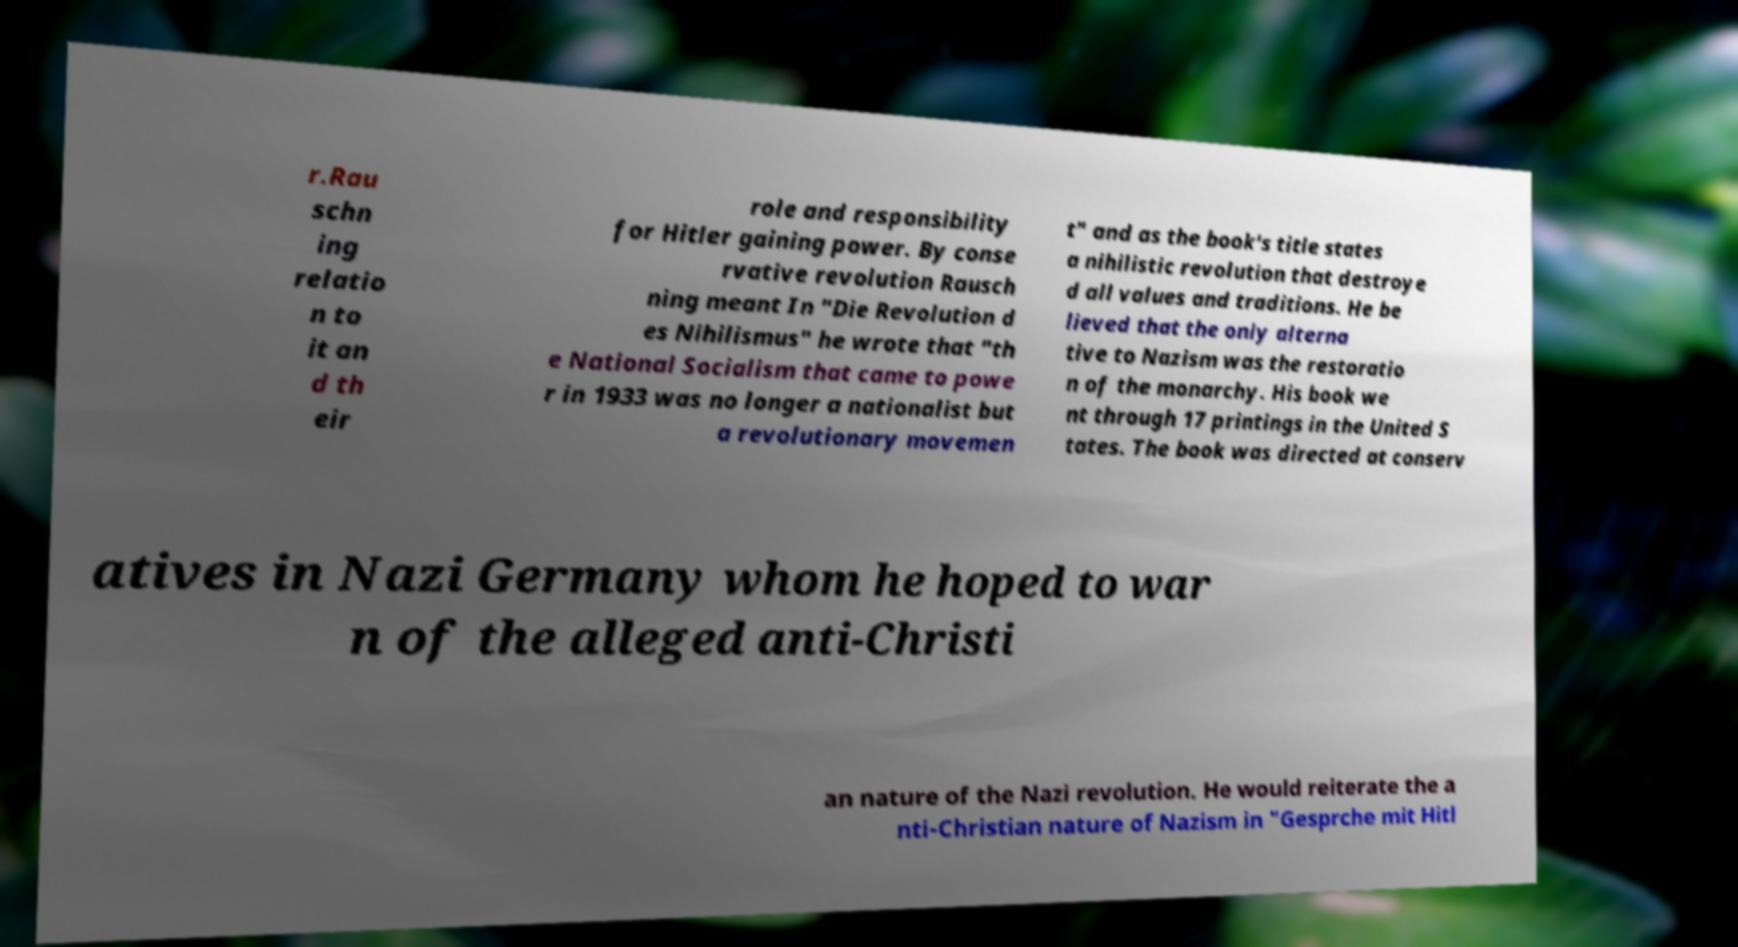What messages or text are displayed in this image? I need them in a readable, typed format. r.Rau schn ing relatio n to it an d th eir role and responsibility for Hitler gaining power. By conse rvative revolution Rausch ning meant In "Die Revolution d es Nihilismus" he wrote that "th e National Socialism that came to powe r in 1933 was no longer a nationalist but a revolutionary movemen t" and as the book's title states a nihilistic revolution that destroye d all values and traditions. He be lieved that the only alterna tive to Nazism was the restoratio n of the monarchy. His book we nt through 17 printings in the United S tates. The book was directed at conserv atives in Nazi Germany whom he hoped to war n of the alleged anti-Christi an nature of the Nazi revolution. He would reiterate the a nti-Christian nature of Nazism in "Gesprche mit Hitl 